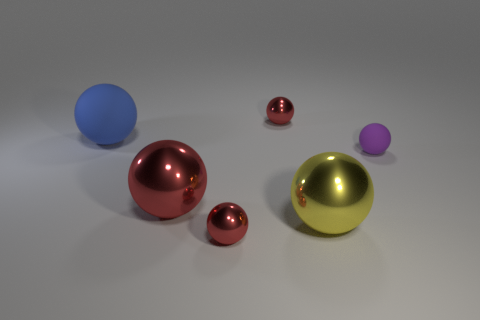Subtract all cyan cylinders. How many red balls are left? 3 Add 1 big blue rubber cubes. How many objects exist? 7 Subtract all red balls. How many balls are left? 3 Subtract all small shiny spheres. How many spheres are left? 4 Subtract all yellow spheres. Subtract all cyan cubes. How many spheres are left? 5 Subtract all tiny purple matte balls. Subtract all blue rubber balls. How many objects are left? 4 Add 6 purple objects. How many purple objects are left? 7 Add 6 large brown objects. How many large brown objects exist? 6 Subtract 0 brown cylinders. How many objects are left? 6 